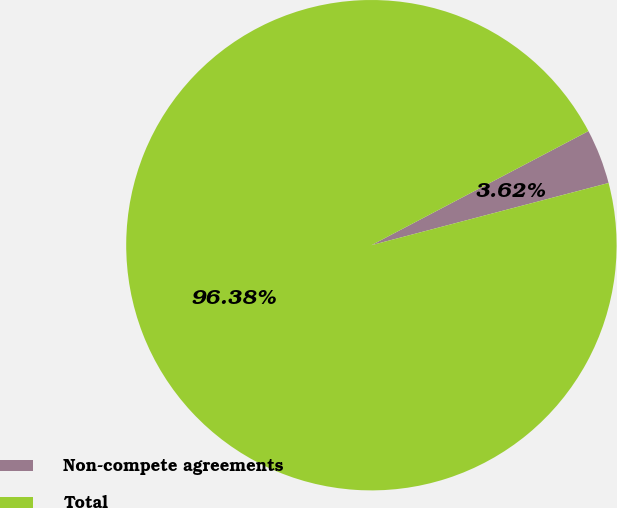Convert chart. <chart><loc_0><loc_0><loc_500><loc_500><pie_chart><fcel>Non-compete agreements<fcel>Total<nl><fcel>3.62%<fcel>96.38%<nl></chart> 